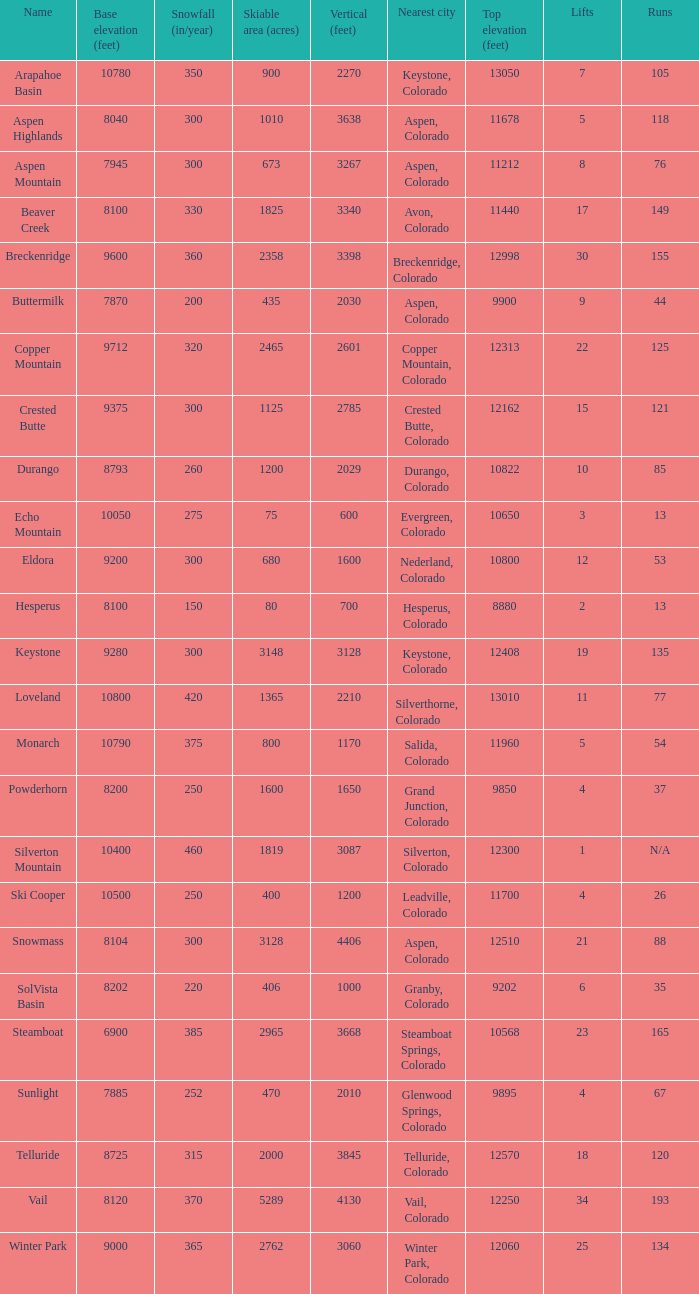How many resorts have 118 runs? 1.0. 